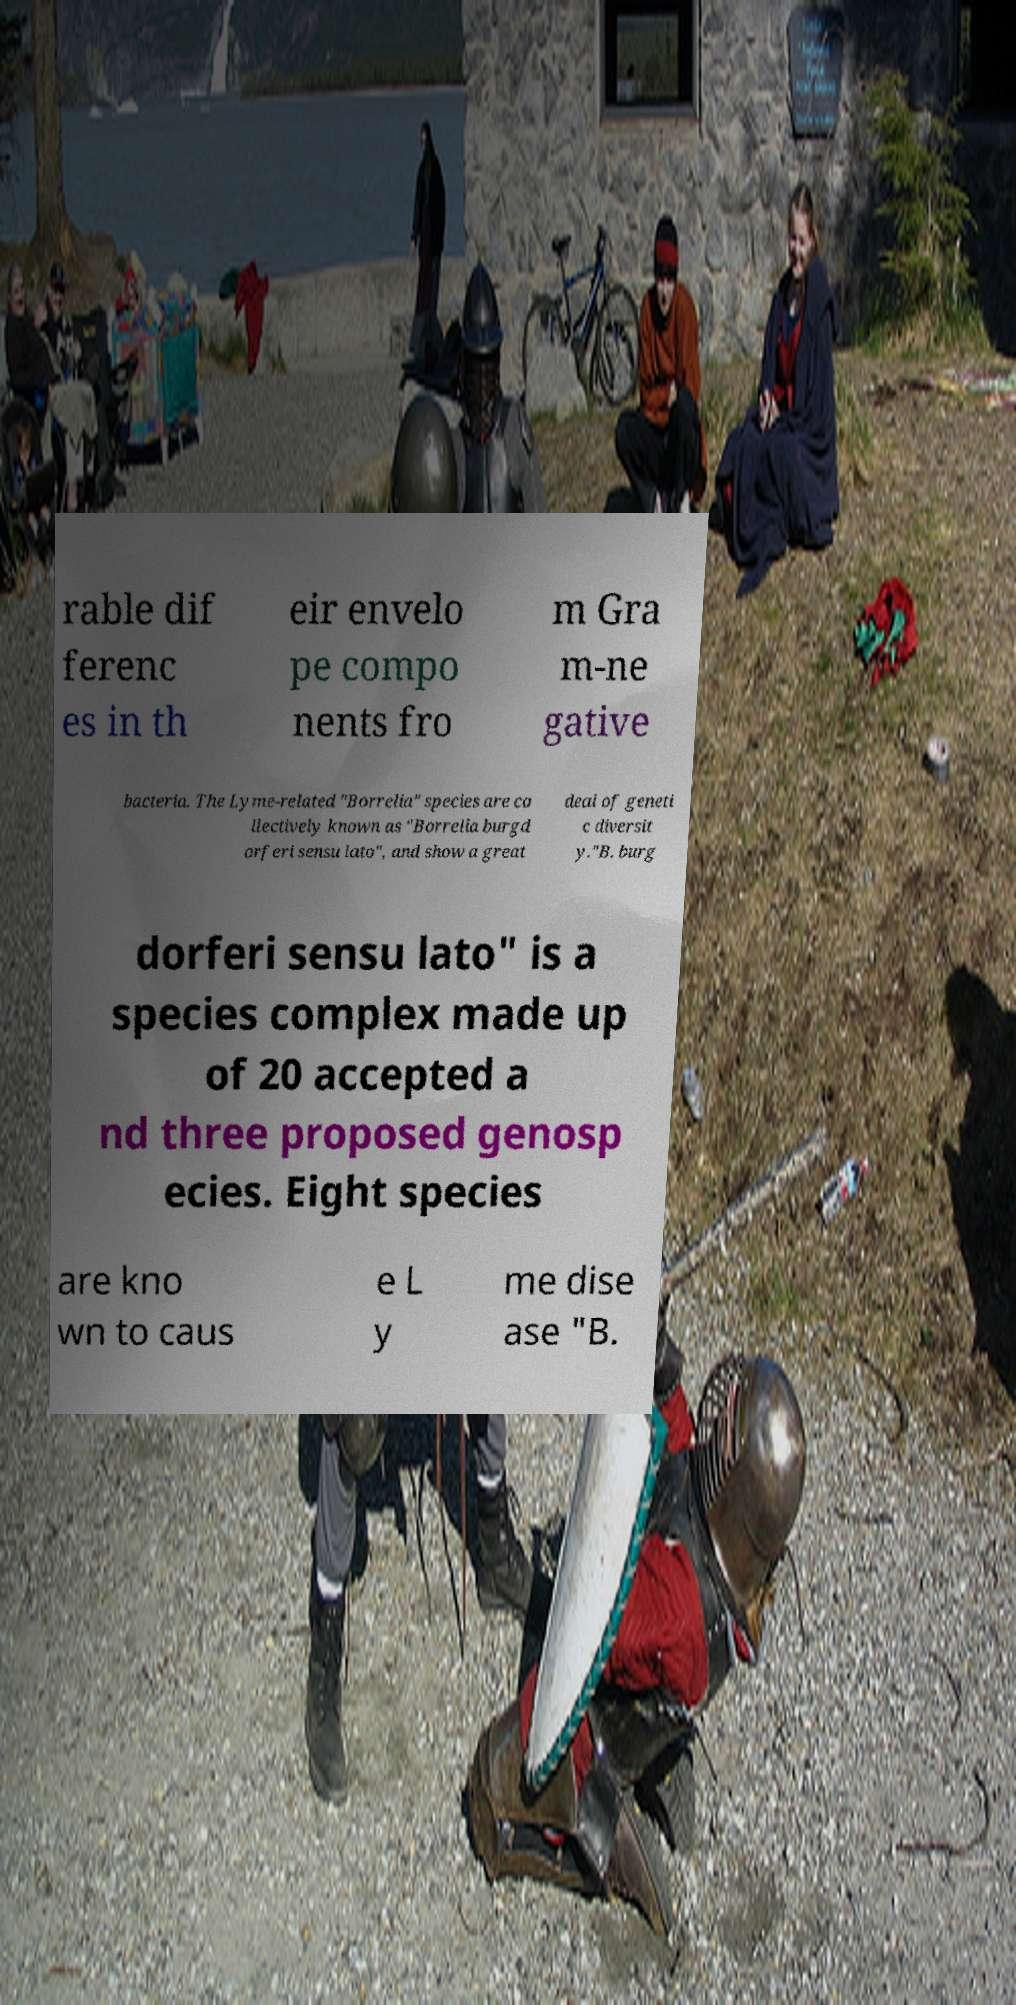For documentation purposes, I need the text within this image transcribed. Could you provide that? rable dif ferenc es in th eir envelo pe compo nents fro m Gra m-ne gative bacteria. The Lyme-related "Borrelia" species are co llectively known as "Borrelia burgd orferi sensu lato", and show a great deal of geneti c diversit y."B. burg dorferi sensu lato" is a species complex made up of 20 accepted a nd three proposed genosp ecies. Eight species are kno wn to caus e L y me dise ase "B. 